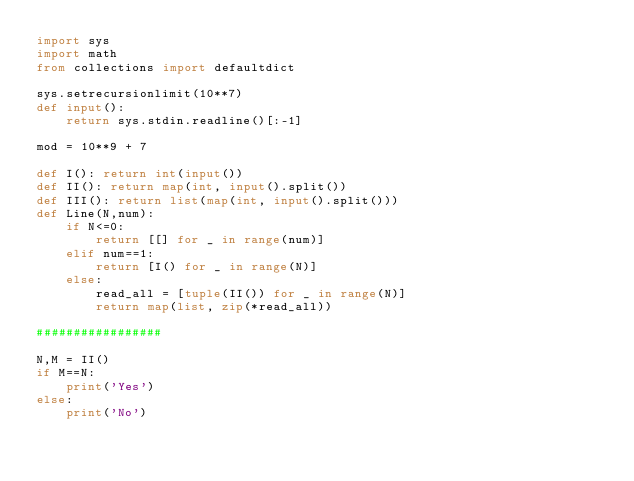Convert code to text. <code><loc_0><loc_0><loc_500><loc_500><_Python_>import sys
import math
from collections import defaultdict

sys.setrecursionlimit(10**7)
def input():
    return sys.stdin.readline()[:-1]

mod = 10**9 + 7

def I(): return int(input())
def II(): return map(int, input().split())
def III(): return list(map(int, input().split()))
def Line(N,num):
    if N<=0:
        return [[] for _ in range(num)]
    elif num==1:
        return [I() for _ in range(N)]
    else:
        read_all = [tuple(II()) for _ in range(N)]
        return map(list, zip(*read_all))

#################

N,M = II()
if M==N:
    print('Yes')
else:
    print('No')
</code> 